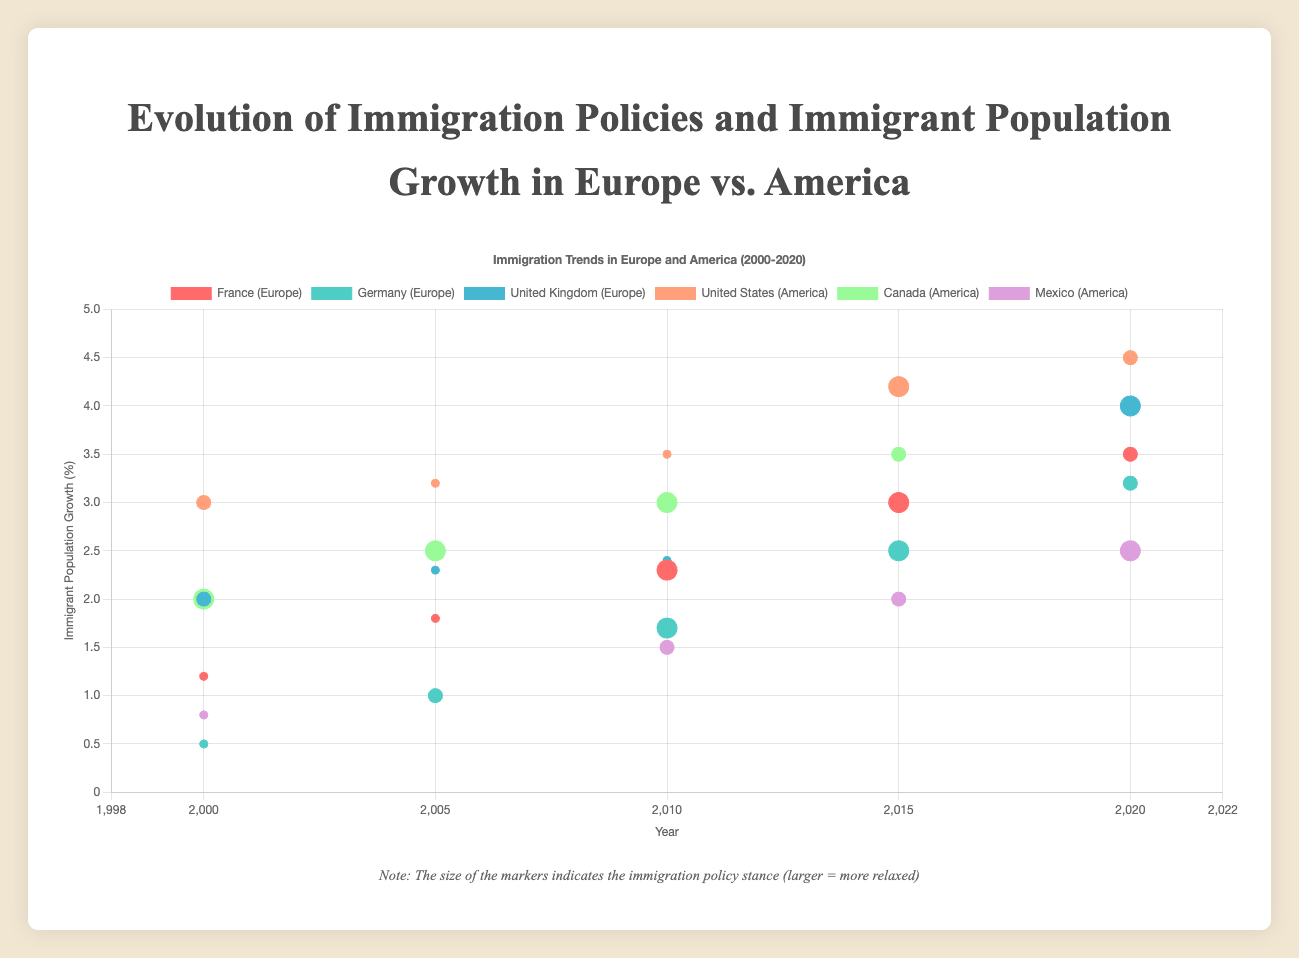Which country in Europe showed the highest immigrant population growth in 2020? To determine this, look at the y-values for the year 2020 for each European country. France shows 3.5%, Germany 3.2%, and the United Kingdom 4.0%.
Answer: United Kingdom What was the trend in immigration policies for the United States from 2000 to 2020? The United States had moderate policies in 2000 and 2020, restrictive policies in 2005 and 2010, and relaxed policies in 2015.
Answer: Mixed (Moderate, Restrictive, Relaxed) Which country has the most consistent immigrant population growth between 2000 and 2020 in America? Consistency here refers to smooth and consistent increasing trends. Canada shows a steady increase from 2.0% in 2000 to 4.0% in 2020.
Answer: Canada How does the immigrant population growth in Germany compare between 2000 and 2020? In 2000, Germany’s growth was 0.5%, and in 2020, it was 3.2%. To find the difference, subtract 0.5 from 3.2.
Answer: 2.7% Between France and the United States, which country had a higher immigrant population growth in 2015? France shows a growth of 3.0% and the United States shows 4.2% in 2015.
Answer: United States If you average the immigrant population growth of France, Germany, and the United Kingdom in 2020, what is the result? Add France (3.5%), Germany (3.2%), and the United Kingdom's (4.0%) growth rates, then divide by 3. This gives (3.5 + 3.2 + 4.0) / 3 = 10.7 / 3.
Answer: 3.57% Which country in America had the biggest increase in immigrant population growth from 2000 to 2020? Calculate the difference for each country: United States (4.5-3.0=1.5), Canada (4.0-2.0=2.0), Mexico (2.5-0.8=1.7). Canada sees the largest increase.
Answer: Canada Which European country shifted from restrictive to relaxed immigration policy first? France shifted to relaxed in 2010, Germany also in 2010, but the United Kingdom only in 2020.
Answer: France and Germany (both in 2010) Is there any year when all three European countries had different immigration policies? In 2000, France and Germany had restrictive policies while the UK had a moderate policy.
Answer: Yes, 2000 In 2015, which continent had a country with the highest immigrant population growth, and which country was it? Compare the 2015 data: France (3.0%), Germany (2.5%), the UK (3.0%) for Europe, and the US (4.2%), Canada (3.5%), and Mexico (2.0%) for America. The United States in America had the highest.
Answer: America, United States 